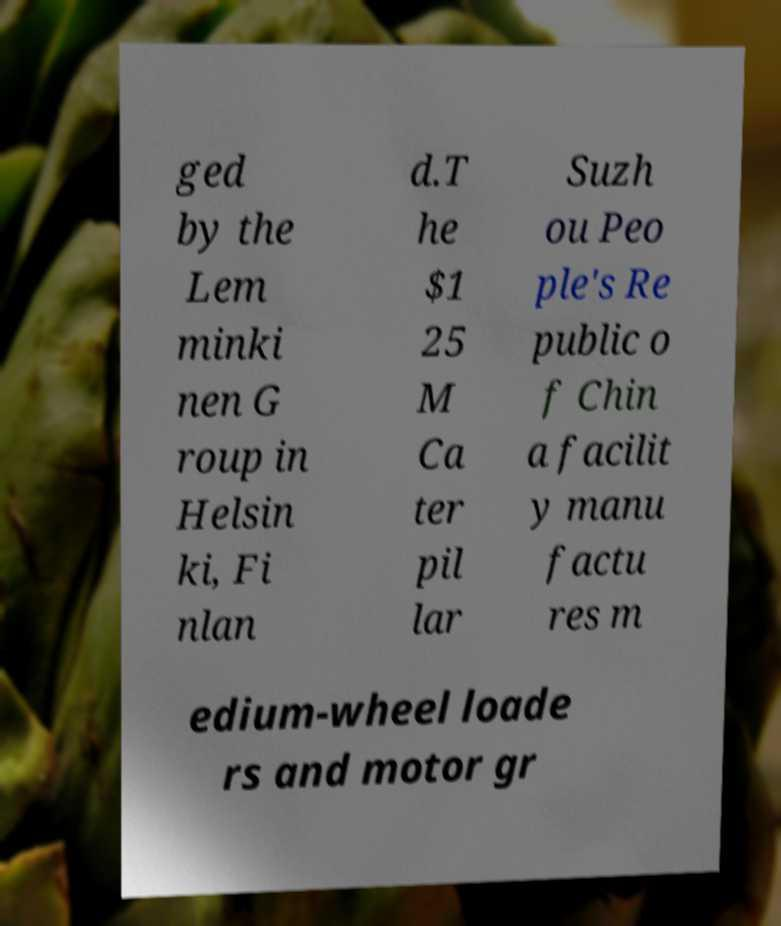For documentation purposes, I need the text within this image transcribed. Could you provide that? ged by the Lem minki nen G roup in Helsin ki, Fi nlan d.T he $1 25 M Ca ter pil lar Suzh ou Peo ple's Re public o f Chin a facilit y manu factu res m edium-wheel loade rs and motor gr 